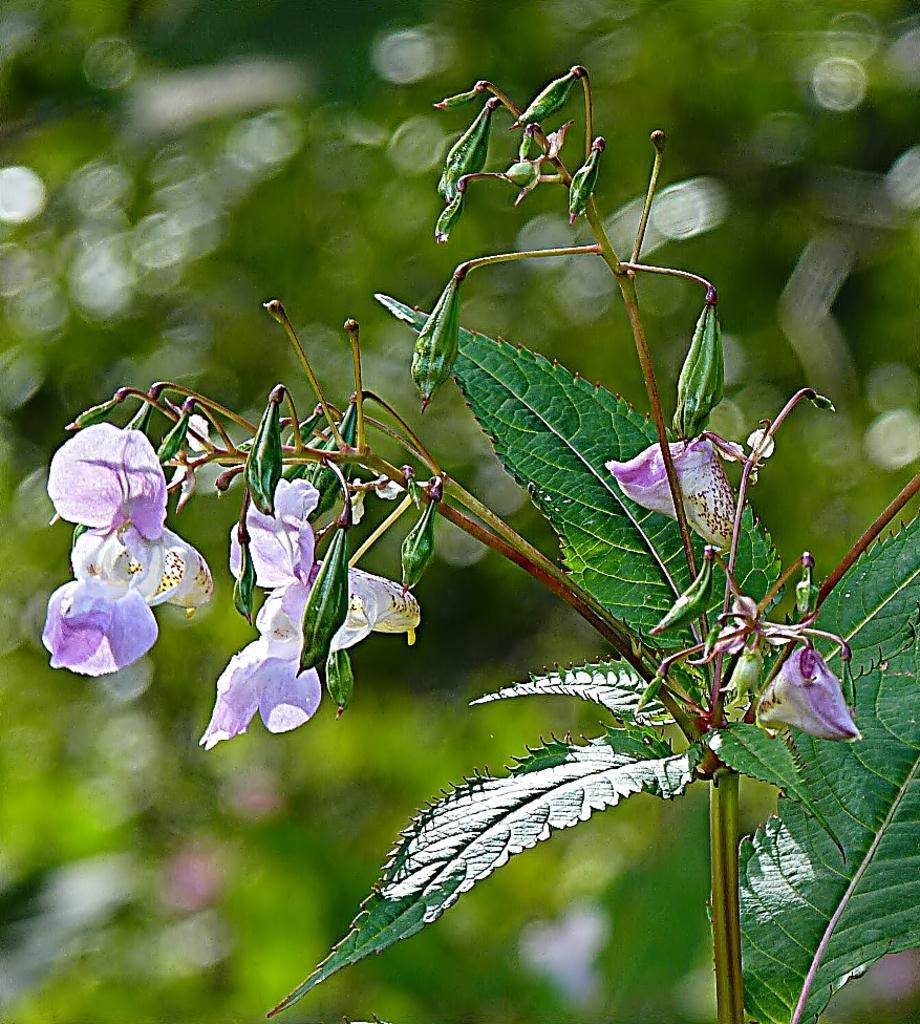Could you give a brief overview of what you see in this image? We can see plant, flowers, buds and green leaves. In the background it is blur and green. 